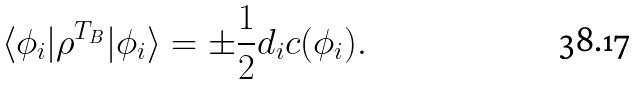Convert formula to latex. <formula><loc_0><loc_0><loc_500><loc_500>\langle \phi _ { i } | \rho ^ { T _ { B } } | \phi _ { i } \rangle = \pm \frac { 1 } { 2 } d _ { i } c ( \phi _ { i } ) .</formula> 